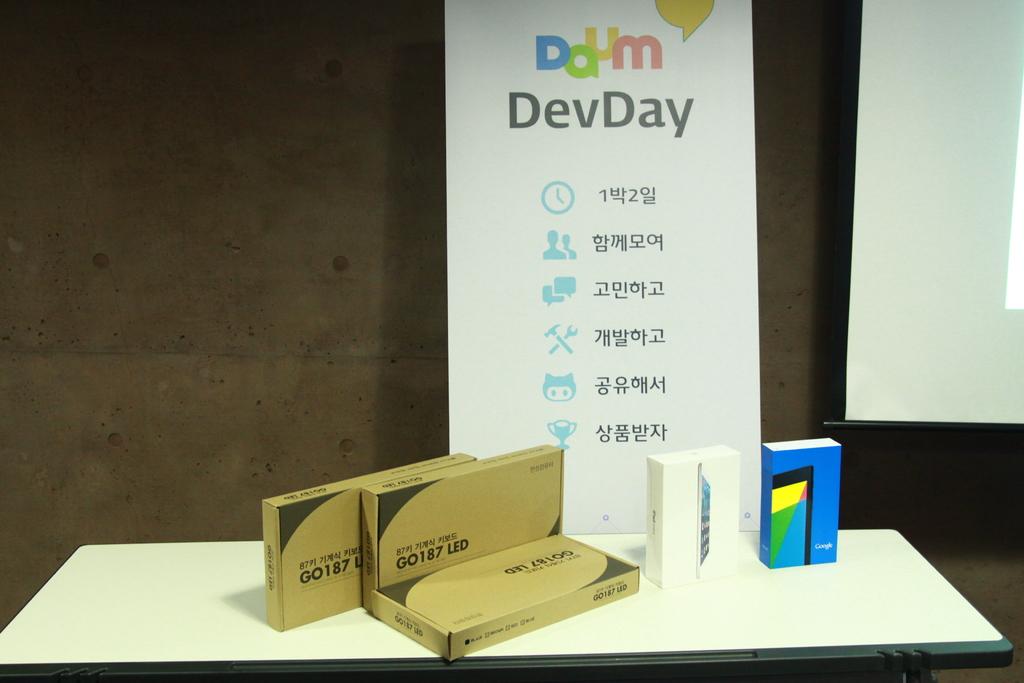What day is it?
Ensure brevity in your answer.  Devday. What letter is capital and displayed twice on the title?
Provide a short and direct response. D. 